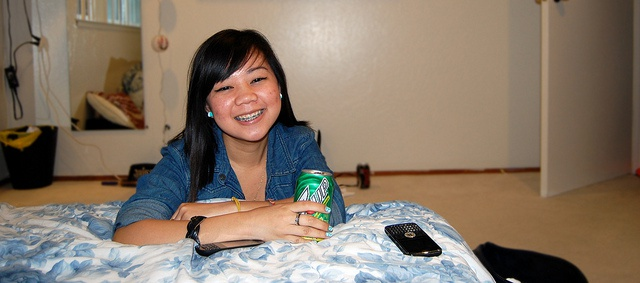Describe the objects in this image and their specific colors. I can see people in gray, black, salmon, navy, and blue tones, bed in gray, lightgray, darkgray, and lightblue tones, cell phone in gray, black, lightgray, and darkgray tones, and cell phone in gray, black, and tan tones in this image. 